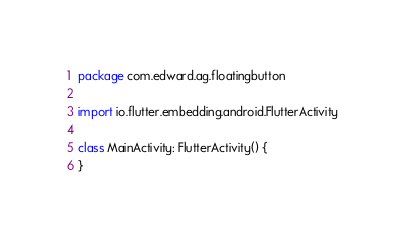Convert code to text. <code><loc_0><loc_0><loc_500><loc_500><_Kotlin_>package com.edward.ag.floatingbutton

import io.flutter.embedding.android.FlutterActivity

class MainActivity: FlutterActivity() {
}
</code> 